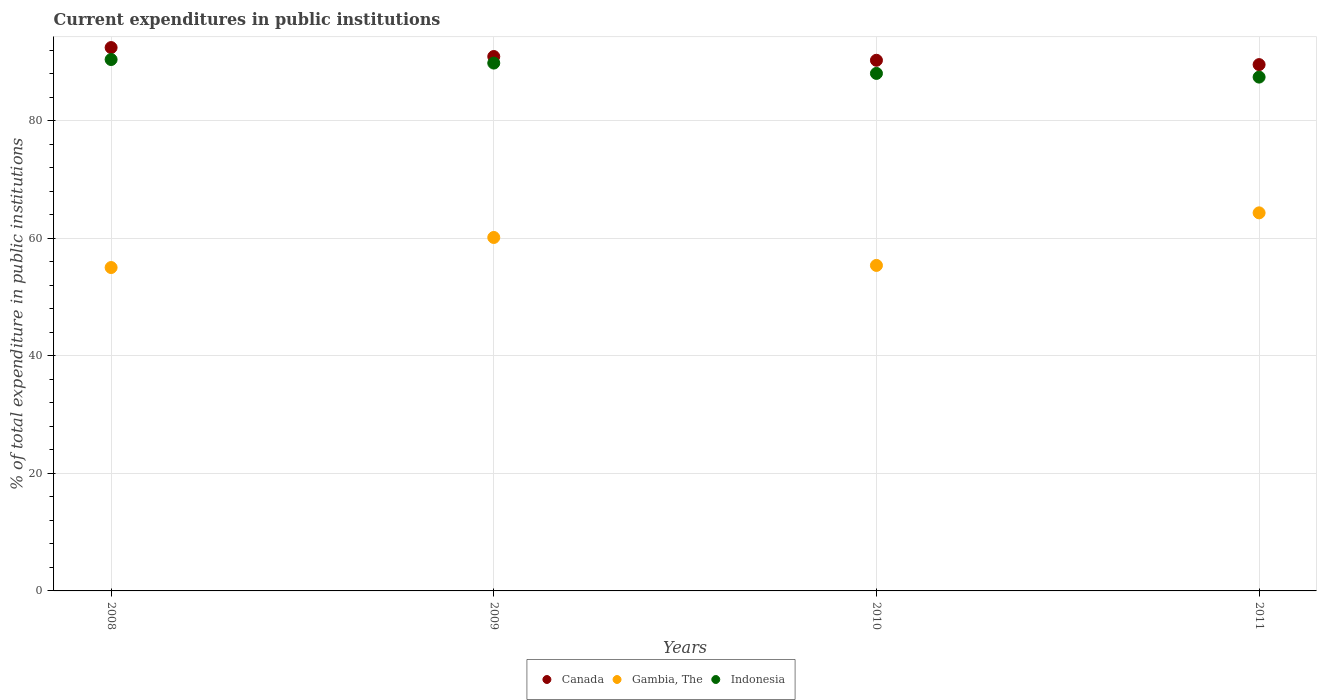Is the number of dotlines equal to the number of legend labels?
Offer a terse response. Yes. What is the current expenditures in public institutions in Gambia, The in 2010?
Ensure brevity in your answer.  55.38. Across all years, what is the maximum current expenditures in public institutions in Canada?
Keep it short and to the point. 92.45. Across all years, what is the minimum current expenditures in public institutions in Canada?
Your answer should be very brief. 89.55. What is the total current expenditures in public institutions in Gambia, The in the graph?
Your answer should be very brief. 234.87. What is the difference between the current expenditures in public institutions in Canada in 2008 and that in 2010?
Your answer should be compact. 2.16. What is the difference between the current expenditures in public institutions in Gambia, The in 2011 and the current expenditures in public institutions in Canada in 2008?
Your answer should be compact. -28.12. What is the average current expenditures in public institutions in Indonesia per year?
Ensure brevity in your answer.  88.93. In the year 2010, what is the difference between the current expenditures in public institutions in Indonesia and current expenditures in public institutions in Canada?
Give a very brief answer. -2.24. What is the ratio of the current expenditures in public institutions in Indonesia in 2008 to that in 2009?
Your response must be concise. 1.01. What is the difference between the highest and the second highest current expenditures in public institutions in Gambia, The?
Ensure brevity in your answer.  4.19. What is the difference between the highest and the lowest current expenditures in public institutions in Indonesia?
Make the answer very short. 2.99. Is it the case that in every year, the sum of the current expenditures in public institutions in Indonesia and current expenditures in public institutions in Gambia, The  is greater than the current expenditures in public institutions in Canada?
Your answer should be compact. Yes. Is the current expenditures in public institutions in Indonesia strictly greater than the current expenditures in public institutions in Canada over the years?
Provide a short and direct response. No. How many years are there in the graph?
Offer a very short reply. 4. What is the difference between two consecutive major ticks on the Y-axis?
Your response must be concise. 20. Are the values on the major ticks of Y-axis written in scientific E-notation?
Provide a succinct answer. No. Does the graph contain grids?
Provide a succinct answer. Yes. Where does the legend appear in the graph?
Keep it short and to the point. Bottom center. What is the title of the graph?
Offer a terse response. Current expenditures in public institutions. Does "Bahrain" appear as one of the legend labels in the graph?
Ensure brevity in your answer.  No. What is the label or title of the Y-axis?
Keep it short and to the point. % of total expenditure in public institutions. What is the % of total expenditure in public institutions of Canada in 2008?
Ensure brevity in your answer.  92.45. What is the % of total expenditure in public institutions in Gambia, The in 2008?
Keep it short and to the point. 55.02. What is the % of total expenditure in public institutions of Indonesia in 2008?
Your answer should be compact. 90.42. What is the % of total expenditure in public institutions in Canada in 2009?
Provide a short and direct response. 90.93. What is the % of total expenditure in public institutions of Gambia, The in 2009?
Provide a succinct answer. 60.14. What is the % of total expenditure in public institutions of Indonesia in 2009?
Keep it short and to the point. 89.81. What is the % of total expenditure in public institutions in Canada in 2010?
Provide a succinct answer. 90.29. What is the % of total expenditure in public institutions in Gambia, The in 2010?
Provide a short and direct response. 55.38. What is the % of total expenditure in public institutions of Indonesia in 2010?
Keep it short and to the point. 88.05. What is the % of total expenditure in public institutions in Canada in 2011?
Give a very brief answer. 89.55. What is the % of total expenditure in public institutions in Gambia, The in 2011?
Provide a succinct answer. 64.33. What is the % of total expenditure in public institutions of Indonesia in 2011?
Give a very brief answer. 87.43. Across all years, what is the maximum % of total expenditure in public institutions in Canada?
Your response must be concise. 92.45. Across all years, what is the maximum % of total expenditure in public institutions in Gambia, The?
Your answer should be very brief. 64.33. Across all years, what is the maximum % of total expenditure in public institutions of Indonesia?
Ensure brevity in your answer.  90.42. Across all years, what is the minimum % of total expenditure in public institutions in Canada?
Provide a short and direct response. 89.55. Across all years, what is the minimum % of total expenditure in public institutions in Gambia, The?
Provide a succinct answer. 55.02. Across all years, what is the minimum % of total expenditure in public institutions of Indonesia?
Provide a succinct answer. 87.43. What is the total % of total expenditure in public institutions of Canada in the graph?
Offer a very short reply. 363.22. What is the total % of total expenditure in public institutions in Gambia, The in the graph?
Keep it short and to the point. 234.87. What is the total % of total expenditure in public institutions of Indonesia in the graph?
Provide a succinct answer. 355.7. What is the difference between the % of total expenditure in public institutions in Canada in 2008 and that in 2009?
Provide a short and direct response. 1.52. What is the difference between the % of total expenditure in public institutions of Gambia, The in 2008 and that in 2009?
Make the answer very short. -5.11. What is the difference between the % of total expenditure in public institutions in Indonesia in 2008 and that in 2009?
Offer a terse response. 0.6. What is the difference between the % of total expenditure in public institutions of Canada in 2008 and that in 2010?
Provide a short and direct response. 2.16. What is the difference between the % of total expenditure in public institutions in Gambia, The in 2008 and that in 2010?
Give a very brief answer. -0.36. What is the difference between the % of total expenditure in public institutions in Indonesia in 2008 and that in 2010?
Provide a short and direct response. 2.36. What is the difference between the % of total expenditure in public institutions in Canada in 2008 and that in 2011?
Your response must be concise. 2.9. What is the difference between the % of total expenditure in public institutions of Gambia, The in 2008 and that in 2011?
Offer a terse response. -9.3. What is the difference between the % of total expenditure in public institutions of Indonesia in 2008 and that in 2011?
Ensure brevity in your answer.  2.99. What is the difference between the % of total expenditure in public institutions in Canada in 2009 and that in 2010?
Your answer should be compact. 0.64. What is the difference between the % of total expenditure in public institutions of Gambia, The in 2009 and that in 2010?
Your response must be concise. 4.75. What is the difference between the % of total expenditure in public institutions of Indonesia in 2009 and that in 2010?
Provide a succinct answer. 1.76. What is the difference between the % of total expenditure in public institutions of Canada in 2009 and that in 2011?
Your answer should be very brief. 1.37. What is the difference between the % of total expenditure in public institutions in Gambia, The in 2009 and that in 2011?
Your answer should be very brief. -4.19. What is the difference between the % of total expenditure in public institutions in Indonesia in 2009 and that in 2011?
Provide a short and direct response. 2.39. What is the difference between the % of total expenditure in public institutions in Canada in 2010 and that in 2011?
Provide a succinct answer. 0.74. What is the difference between the % of total expenditure in public institutions of Gambia, The in 2010 and that in 2011?
Give a very brief answer. -8.94. What is the difference between the % of total expenditure in public institutions of Indonesia in 2010 and that in 2011?
Offer a very short reply. 0.63. What is the difference between the % of total expenditure in public institutions in Canada in 2008 and the % of total expenditure in public institutions in Gambia, The in 2009?
Your response must be concise. 32.31. What is the difference between the % of total expenditure in public institutions of Canada in 2008 and the % of total expenditure in public institutions of Indonesia in 2009?
Offer a terse response. 2.64. What is the difference between the % of total expenditure in public institutions in Gambia, The in 2008 and the % of total expenditure in public institutions in Indonesia in 2009?
Your response must be concise. -34.79. What is the difference between the % of total expenditure in public institutions of Canada in 2008 and the % of total expenditure in public institutions of Gambia, The in 2010?
Provide a short and direct response. 37.07. What is the difference between the % of total expenditure in public institutions in Canada in 2008 and the % of total expenditure in public institutions in Indonesia in 2010?
Give a very brief answer. 4.4. What is the difference between the % of total expenditure in public institutions of Gambia, The in 2008 and the % of total expenditure in public institutions of Indonesia in 2010?
Keep it short and to the point. -33.03. What is the difference between the % of total expenditure in public institutions of Canada in 2008 and the % of total expenditure in public institutions of Gambia, The in 2011?
Keep it short and to the point. 28.12. What is the difference between the % of total expenditure in public institutions in Canada in 2008 and the % of total expenditure in public institutions in Indonesia in 2011?
Provide a short and direct response. 5.02. What is the difference between the % of total expenditure in public institutions of Gambia, The in 2008 and the % of total expenditure in public institutions of Indonesia in 2011?
Your answer should be very brief. -32.4. What is the difference between the % of total expenditure in public institutions in Canada in 2009 and the % of total expenditure in public institutions in Gambia, The in 2010?
Keep it short and to the point. 35.54. What is the difference between the % of total expenditure in public institutions in Canada in 2009 and the % of total expenditure in public institutions in Indonesia in 2010?
Give a very brief answer. 2.87. What is the difference between the % of total expenditure in public institutions in Gambia, The in 2009 and the % of total expenditure in public institutions in Indonesia in 2010?
Give a very brief answer. -27.91. What is the difference between the % of total expenditure in public institutions of Canada in 2009 and the % of total expenditure in public institutions of Gambia, The in 2011?
Provide a short and direct response. 26.6. What is the difference between the % of total expenditure in public institutions in Canada in 2009 and the % of total expenditure in public institutions in Indonesia in 2011?
Offer a very short reply. 3.5. What is the difference between the % of total expenditure in public institutions in Gambia, The in 2009 and the % of total expenditure in public institutions in Indonesia in 2011?
Provide a succinct answer. -27.29. What is the difference between the % of total expenditure in public institutions of Canada in 2010 and the % of total expenditure in public institutions of Gambia, The in 2011?
Your answer should be very brief. 25.96. What is the difference between the % of total expenditure in public institutions in Canada in 2010 and the % of total expenditure in public institutions in Indonesia in 2011?
Offer a very short reply. 2.86. What is the difference between the % of total expenditure in public institutions of Gambia, The in 2010 and the % of total expenditure in public institutions of Indonesia in 2011?
Provide a short and direct response. -32.04. What is the average % of total expenditure in public institutions in Canada per year?
Your response must be concise. 90.8. What is the average % of total expenditure in public institutions of Gambia, The per year?
Keep it short and to the point. 58.72. What is the average % of total expenditure in public institutions in Indonesia per year?
Your response must be concise. 88.93. In the year 2008, what is the difference between the % of total expenditure in public institutions in Canada and % of total expenditure in public institutions in Gambia, The?
Give a very brief answer. 37.43. In the year 2008, what is the difference between the % of total expenditure in public institutions in Canada and % of total expenditure in public institutions in Indonesia?
Make the answer very short. 2.03. In the year 2008, what is the difference between the % of total expenditure in public institutions in Gambia, The and % of total expenditure in public institutions in Indonesia?
Your response must be concise. -35.39. In the year 2009, what is the difference between the % of total expenditure in public institutions of Canada and % of total expenditure in public institutions of Gambia, The?
Provide a succinct answer. 30.79. In the year 2009, what is the difference between the % of total expenditure in public institutions in Canada and % of total expenditure in public institutions in Indonesia?
Your answer should be very brief. 1.11. In the year 2009, what is the difference between the % of total expenditure in public institutions in Gambia, The and % of total expenditure in public institutions in Indonesia?
Give a very brief answer. -29.67. In the year 2010, what is the difference between the % of total expenditure in public institutions in Canada and % of total expenditure in public institutions in Gambia, The?
Provide a short and direct response. 34.91. In the year 2010, what is the difference between the % of total expenditure in public institutions of Canada and % of total expenditure in public institutions of Indonesia?
Your response must be concise. 2.24. In the year 2010, what is the difference between the % of total expenditure in public institutions of Gambia, The and % of total expenditure in public institutions of Indonesia?
Your response must be concise. -32.67. In the year 2011, what is the difference between the % of total expenditure in public institutions in Canada and % of total expenditure in public institutions in Gambia, The?
Offer a very short reply. 25.22. In the year 2011, what is the difference between the % of total expenditure in public institutions of Canada and % of total expenditure in public institutions of Indonesia?
Provide a short and direct response. 2.13. In the year 2011, what is the difference between the % of total expenditure in public institutions in Gambia, The and % of total expenditure in public institutions in Indonesia?
Provide a short and direct response. -23.1. What is the ratio of the % of total expenditure in public institutions in Canada in 2008 to that in 2009?
Provide a short and direct response. 1.02. What is the ratio of the % of total expenditure in public institutions of Gambia, The in 2008 to that in 2009?
Your answer should be very brief. 0.92. What is the ratio of the % of total expenditure in public institutions of Indonesia in 2008 to that in 2009?
Provide a short and direct response. 1.01. What is the ratio of the % of total expenditure in public institutions in Canada in 2008 to that in 2010?
Make the answer very short. 1.02. What is the ratio of the % of total expenditure in public institutions in Indonesia in 2008 to that in 2010?
Your answer should be very brief. 1.03. What is the ratio of the % of total expenditure in public institutions in Canada in 2008 to that in 2011?
Ensure brevity in your answer.  1.03. What is the ratio of the % of total expenditure in public institutions in Gambia, The in 2008 to that in 2011?
Make the answer very short. 0.86. What is the ratio of the % of total expenditure in public institutions in Indonesia in 2008 to that in 2011?
Make the answer very short. 1.03. What is the ratio of the % of total expenditure in public institutions of Canada in 2009 to that in 2010?
Offer a terse response. 1.01. What is the ratio of the % of total expenditure in public institutions of Gambia, The in 2009 to that in 2010?
Offer a very short reply. 1.09. What is the ratio of the % of total expenditure in public institutions in Canada in 2009 to that in 2011?
Your answer should be very brief. 1.02. What is the ratio of the % of total expenditure in public institutions of Gambia, The in 2009 to that in 2011?
Ensure brevity in your answer.  0.93. What is the ratio of the % of total expenditure in public institutions of Indonesia in 2009 to that in 2011?
Provide a succinct answer. 1.03. What is the ratio of the % of total expenditure in public institutions of Canada in 2010 to that in 2011?
Offer a terse response. 1.01. What is the ratio of the % of total expenditure in public institutions in Gambia, The in 2010 to that in 2011?
Your answer should be compact. 0.86. What is the difference between the highest and the second highest % of total expenditure in public institutions of Canada?
Offer a very short reply. 1.52. What is the difference between the highest and the second highest % of total expenditure in public institutions in Gambia, The?
Your response must be concise. 4.19. What is the difference between the highest and the second highest % of total expenditure in public institutions of Indonesia?
Make the answer very short. 0.6. What is the difference between the highest and the lowest % of total expenditure in public institutions in Canada?
Your answer should be compact. 2.9. What is the difference between the highest and the lowest % of total expenditure in public institutions in Gambia, The?
Offer a very short reply. 9.3. What is the difference between the highest and the lowest % of total expenditure in public institutions of Indonesia?
Offer a very short reply. 2.99. 